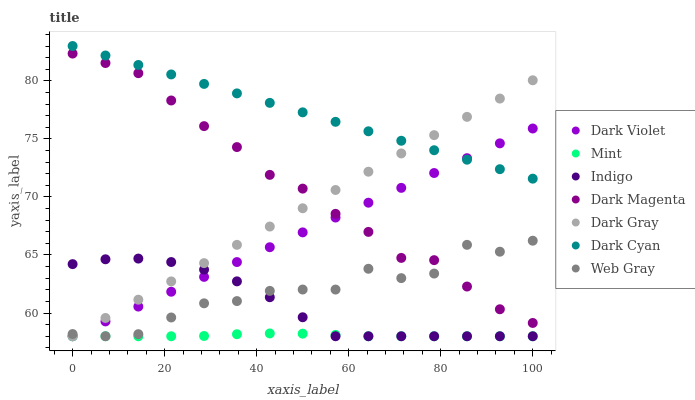Does Mint have the minimum area under the curve?
Answer yes or no. Yes. Does Dark Cyan have the maximum area under the curve?
Answer yes or no. Yes. Does Indigo have the minimum area under the curve?
Answer yes or no. No. Does Indigo have the maximum area under the curve?
Answer yes or no. No. Is Dark Violet the smoothest?
Answer yes or no. Yes. Is Web Gray the roughest?
Answer yes or no. Yes. Is Indigo the smoothest?
Answer yes or no. No. Is Indigo the roughest?
Answer yes or no. No. Does Web Gray have the lowest value?
Answer yes or no. Yes. Does Dark Magenta have the lowest value?
Answer yes or no. No. Does Dark Cyan have the highest value?
Answer yes or no. Yes. Does Indigo have the highest value?
Answer yes or no. No. Is Dark Magenta less than Dark Cyan?
Answer yes or no. Yes. Is Dark Cyan greater than Web Gray?
Answer yes or no. Yes. Does Indigo intersect Web Gray?
Answer yes or no. Yes. Is Indigo less than Web Gray?
Answer yes or no. No. Is Indigo greater than Web Gray?
Answer yes or no. No. Does Dark Magenta intersect Dark Cyan?
Answer yes or no. No. 